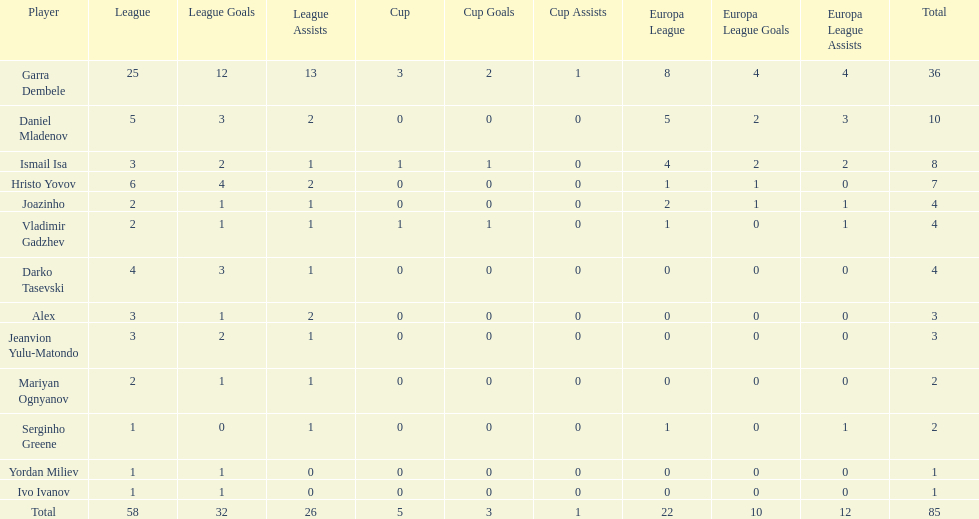Which total is higher, the europa league total or the league total? League. 